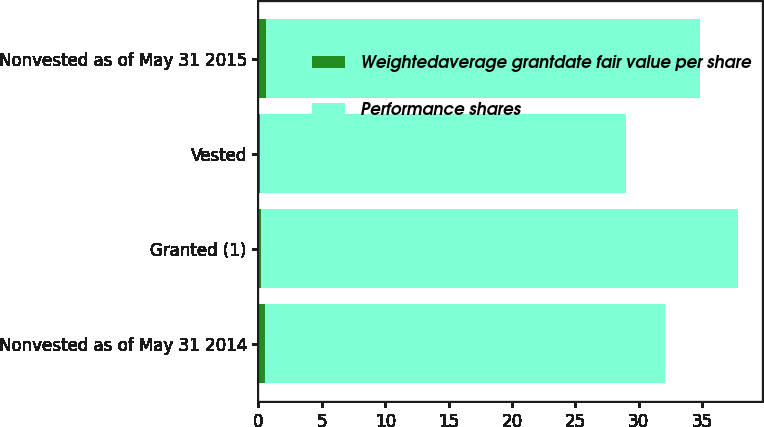Convert chart. <chart><loc_0><loc_0><loc_500><loc_500><stacked_bar_chart><ecel><fcel>Nonvested as of May 31 2014<fcel>Granted (1)<fcel>Vested<fcel>Nonvested as of May 31 2015<nl><fcel>Weightedaverage grantdate fair value per share<fcel>0.5<fcel>0.2<fcel>0.1<fcel>0.6<nl><fcel>Performance shares<fcel>31.61<fcel>37.61<fcel>28.87<fcel>34.24<nl></chart> 